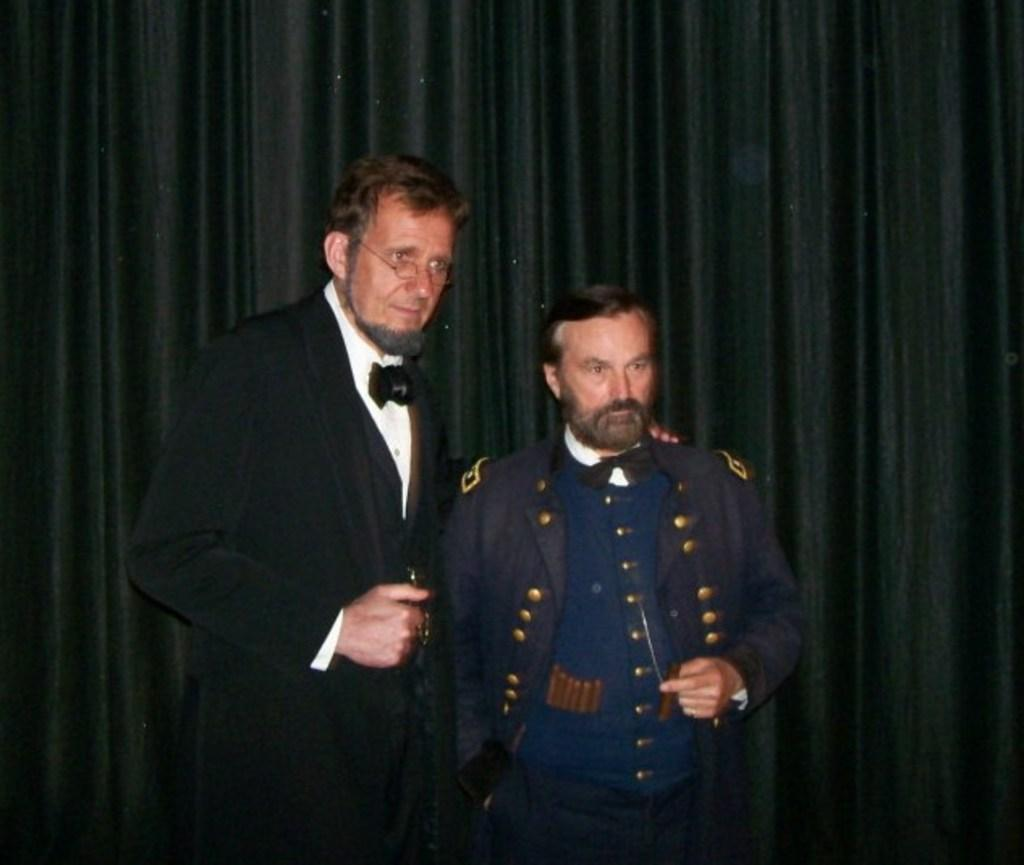How many people are in the image? There are two men in the image. What are the men doing in the image? The men are standing in the image. What are the men wearing in the image? The men are wearing suits in the image. What can be seen in the background of the image? There is a black curtain in the background of the image. What is the tendency of the money in the image? There is no money present in the image, so it is not possible to determine any tendency. 